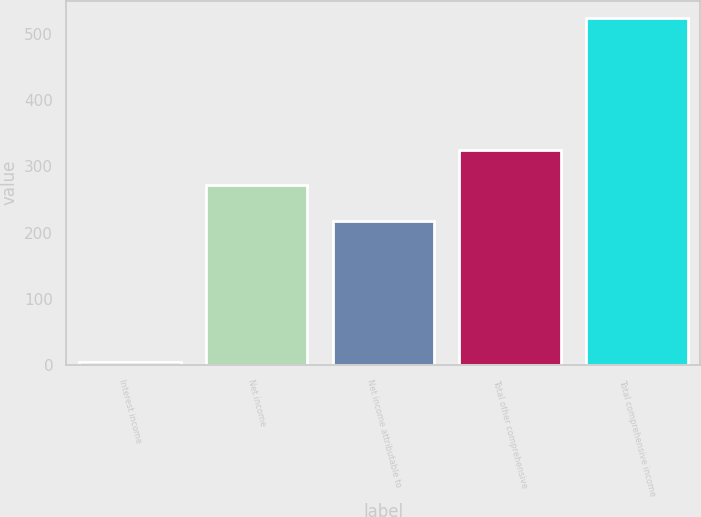Convert chart. <chart><loc_0><loc_0><loc_500><loc_500><bar_chart><fcel>Interest income<fcel>Net income<fcel>Net income attributable to<fcel>Total other comprehensive<fcel>Total comprehensive income<nl><fcel>4<fcel>271.3<fcel>218<fcel>324.6<fcel>524<nl></chart> 